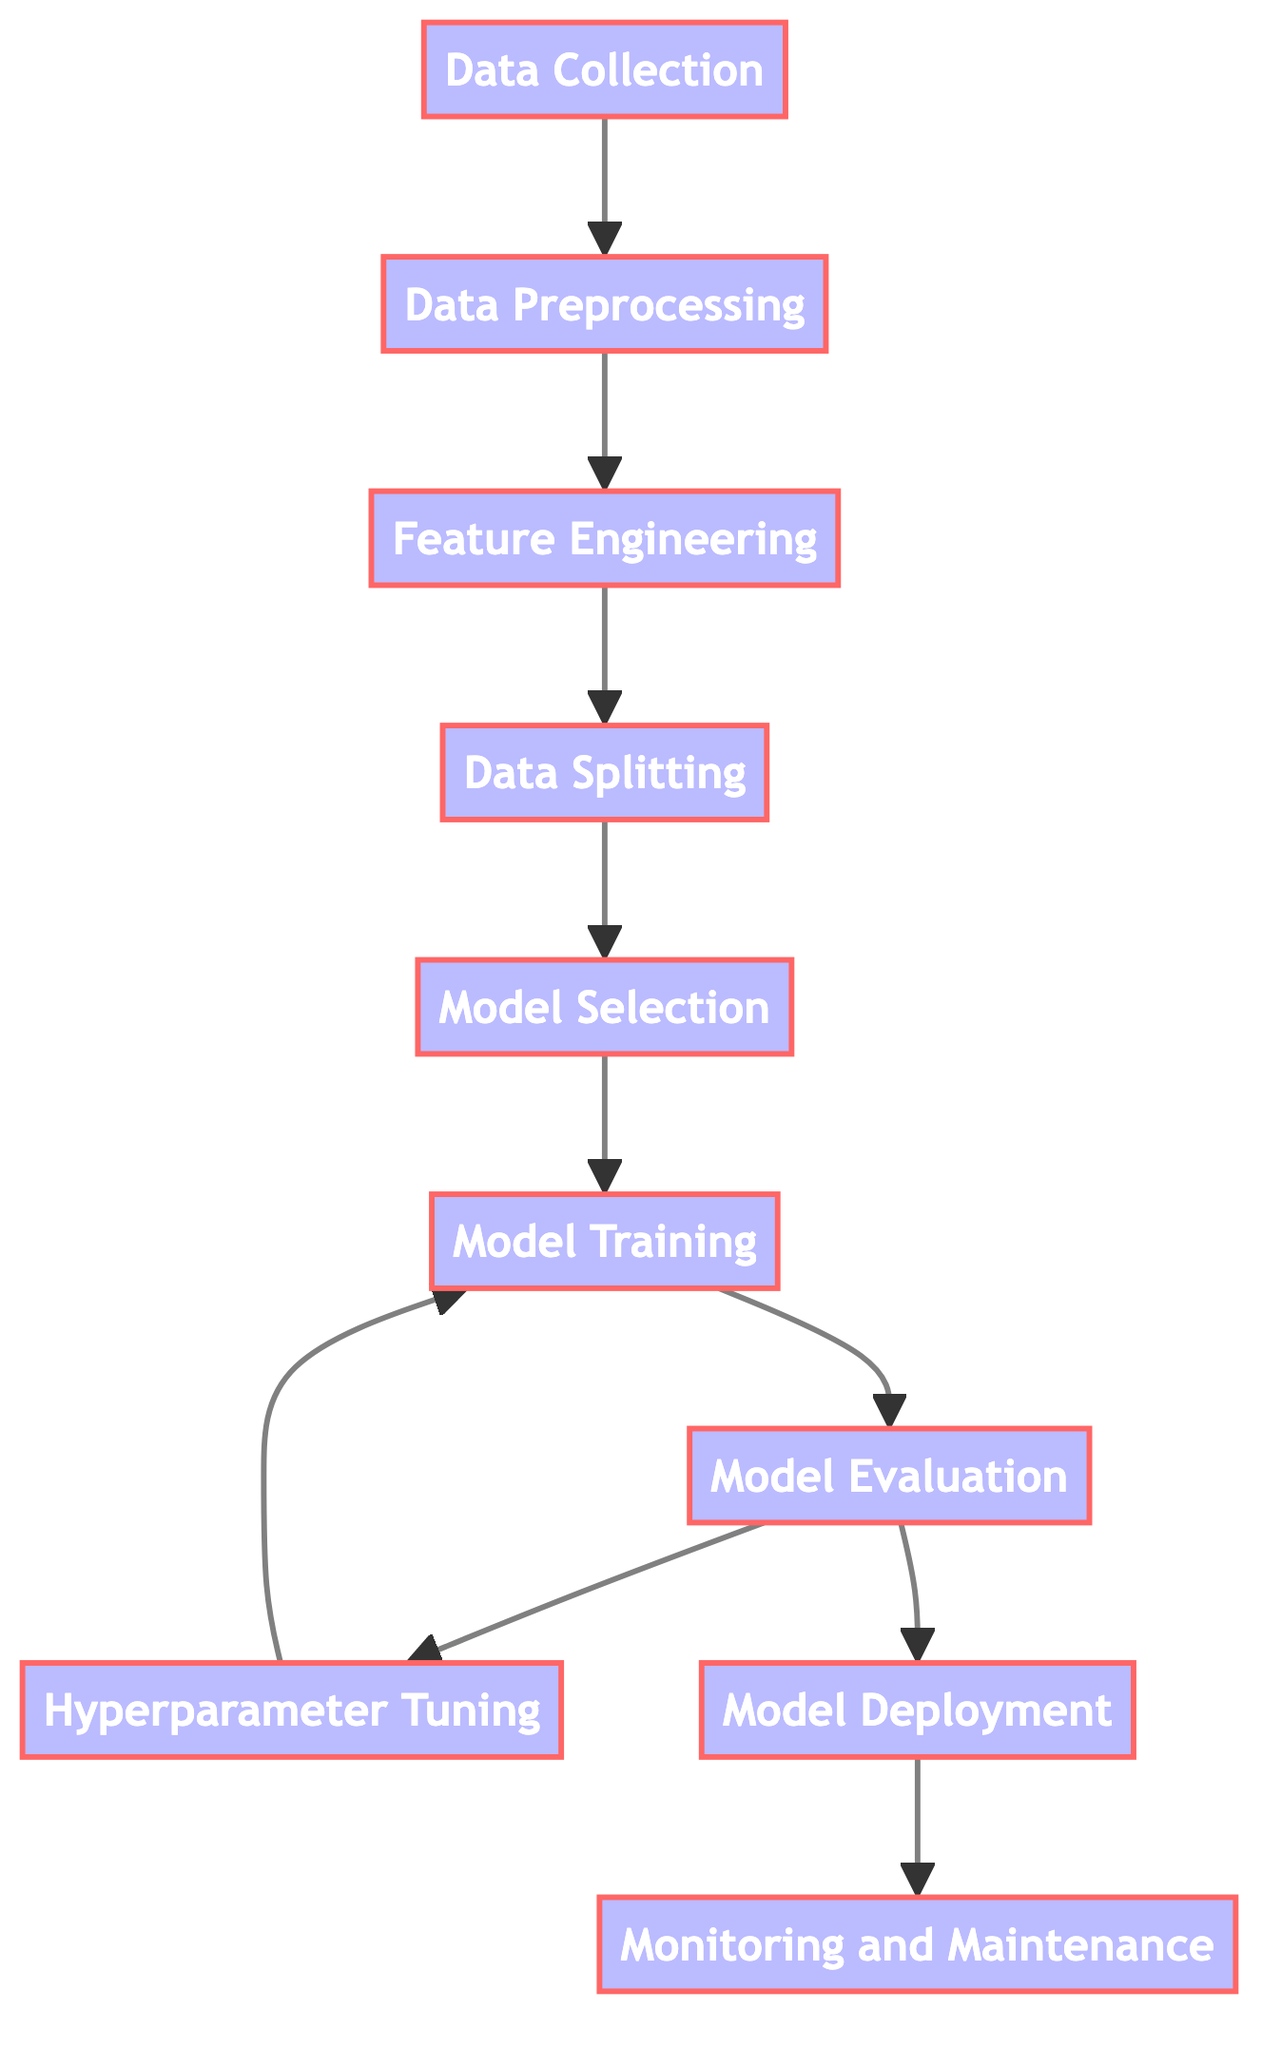What is the first step in the diagram? The first step according to the diagram is 'Data Collection,' which is represented as node A. This node directly connects to the next step, indicating it is the starting point of the process.
Answer: Data Collection How many total steps are involved in the process? By counting all the nodes in the diagram, we see there are a total of 10 steps, including 'Monitoring and Maintenance.' Each node represents a stage in the predictive modeling process.
Answer: 10 Which step follows 'Model Training'? 'Model Evaluation' follows 'Model Training' in the flowchart. This relationship is clear as there is a direct arrow pointing to 'Model Evaluation' from 'Model Training.'
Answer: Model Evaluation What step does 'Hyperparameter Tuning' link back to? 'Hyperparameter Tuning' has a direct link back to 'Model Training,' indicating a cycle where the model is further refined after evaluation. This suggests an iterative approach to improve the model's performance.
Answer: Model Training What is the last step in the process? The last step of the process is 'Monitoring and Maintenance,' which is represented as node J and follows 'Model Deployment' in the flowchart, indicating the final stage of the model's lifecycle.
Answer: Monitoring and Maintenance Which step comes directly before 'Model Deployment'? Directly before 'Model Deployment' in the diagram is 'Model Evaluation'. This shows a sequential process where evaluation is done prior to deploying the model.
Answer: Model Evaluation What is the relationship between 'Data Splitting' and 'Model Selection'? In the flowchart, there is a direct connection from 'Data Splitting' to 'Model Selection,' indicating that after the data is split, the next logical step is to select the appropriate model to use.
Answer: Direct connection What processes are involved before 'Model Training'? The processes that occur before 'Model Training' include 'Feature Engineering,' 'Data Splitting,' and 'Model Selection,' showing a clear pipeline leading up to training the model.
Answer: Feature Engineering, Data Splitting, Model Selection What is the purpose of 'Monitoring and Maintenance'? 'Monitoring and Maintenance' is designed to ensure that the deployed model continues to operate effectively and remains relevant over time, tracking its performance and making adjustments as necessary.
Answer: Ensure performance and relevance 